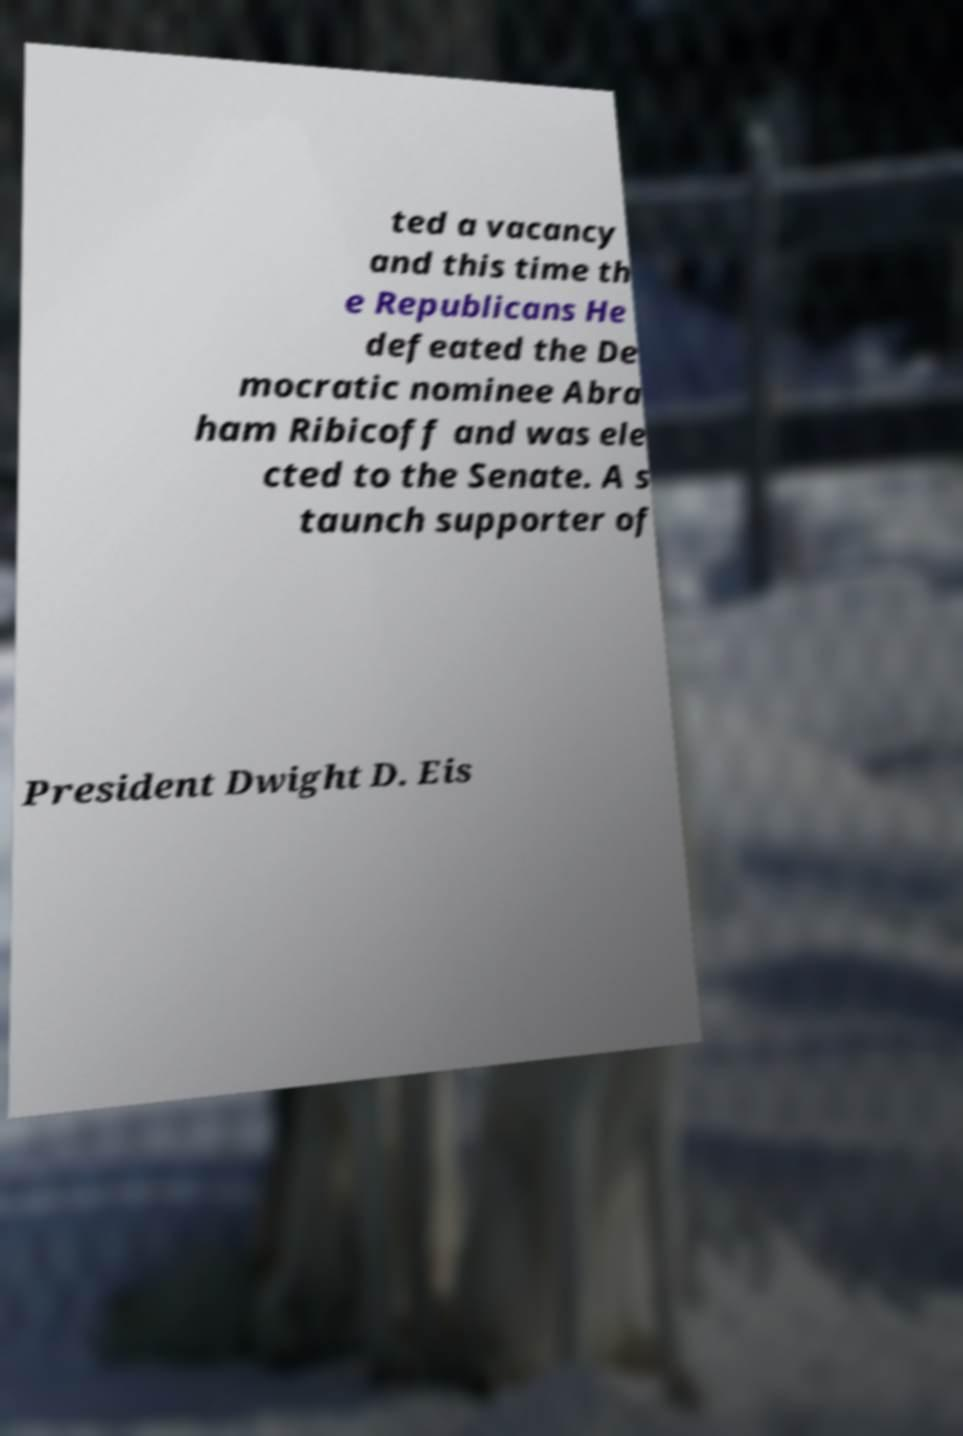For documentation purposes, I need the text within this image transcribed. Could you provide that? ted a vacancy and this time th e Republicans He defeated the De mocratic nominee Abra ham Ribicoff and was ele cted to the Senate. A s taunch supporter of President Dwight D. Eis 